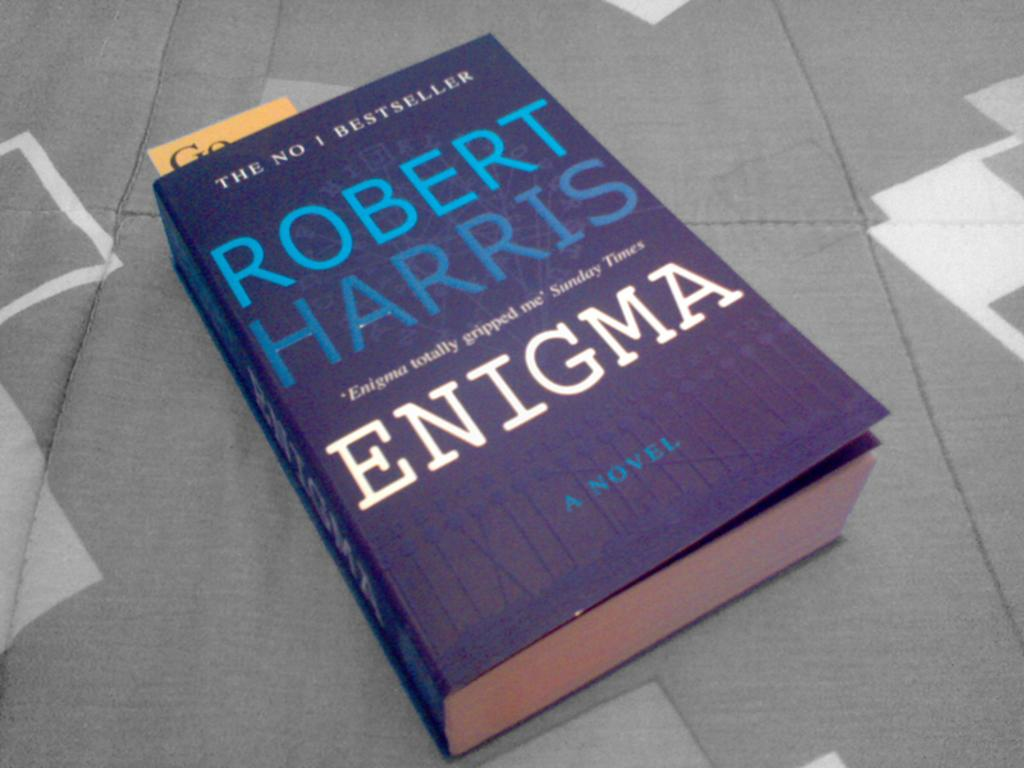<image>
Provide a brief description of the given image. The number one bestseller Robert Harris Enigma chapter book laid on a cover. 